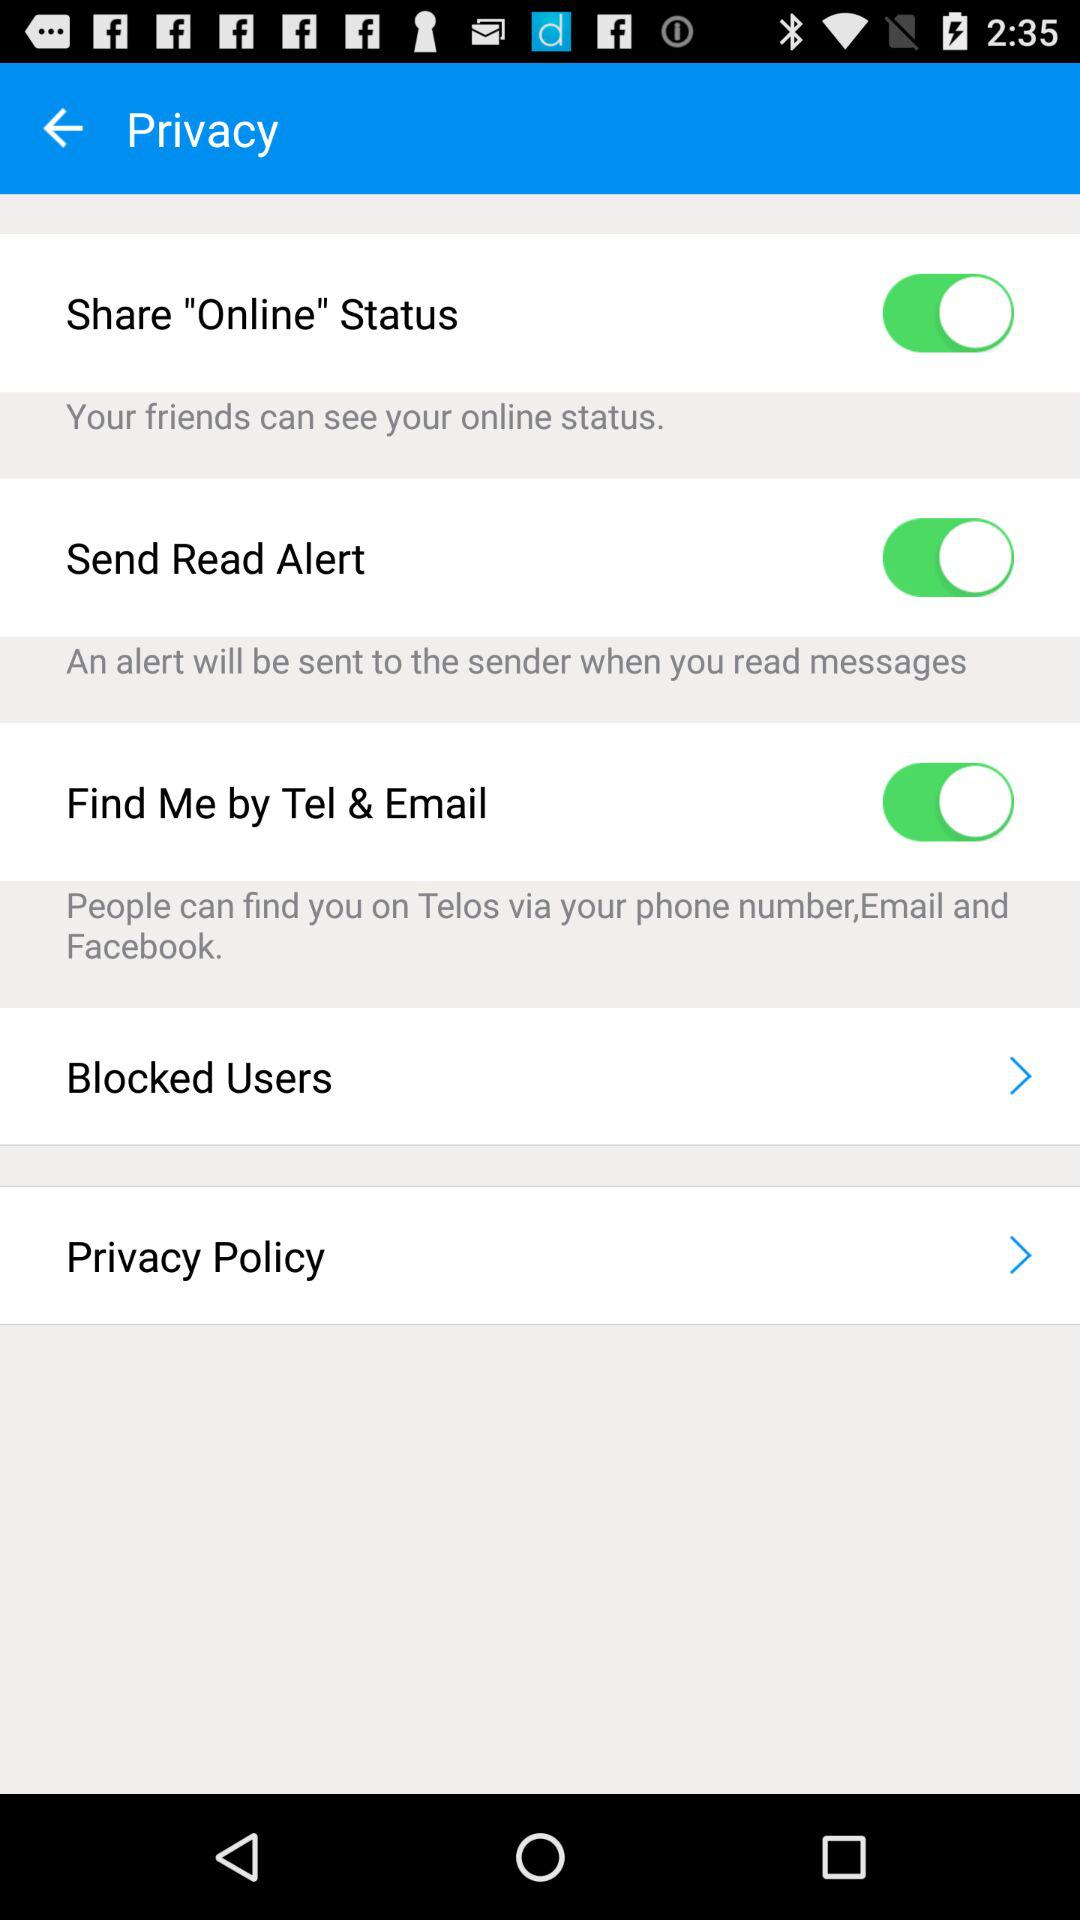How can people find me on Telos? People can find you on Telos by phone number, email and Facebook. 